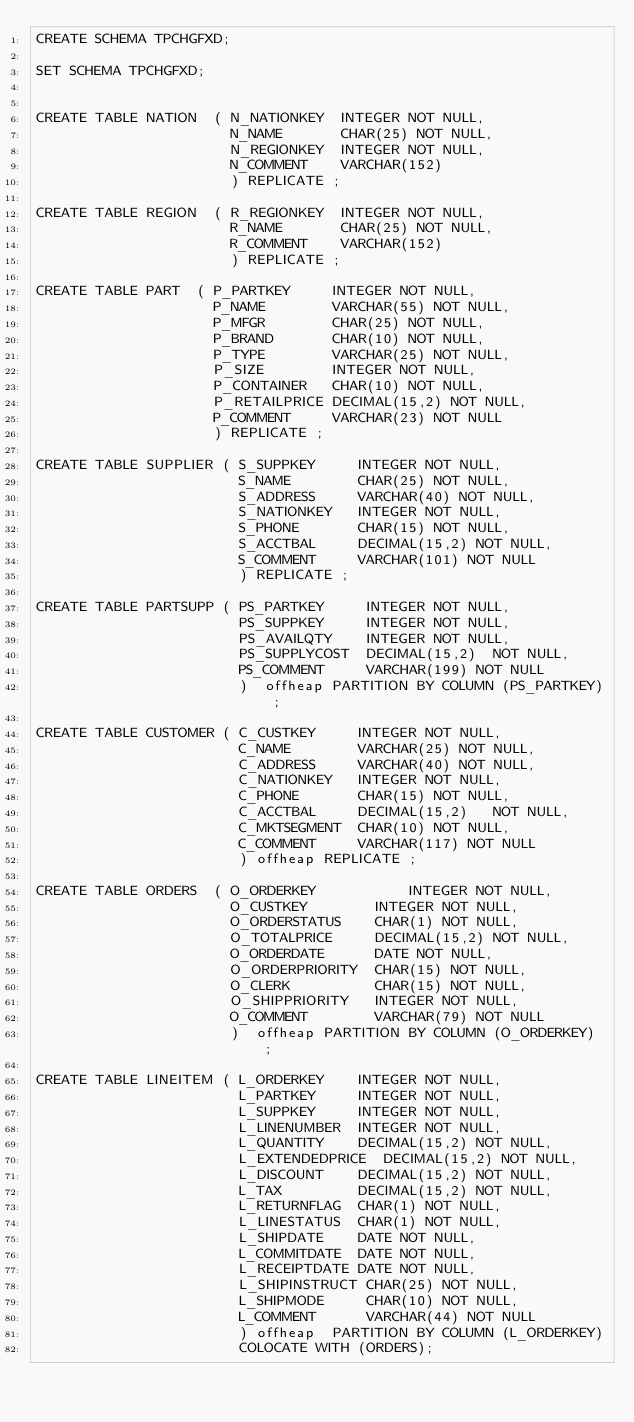<code> <loc_0><loc_0><loc_500><loc_500><_SQL_>CREATE SCHEMA TPCHGFXD;

SET SCHEMA TPCHGFXD;


CREATE TABLE NATION  ( N_NATIONKEY  INTEGER NOT NULL,
                       N_NAME       CHAR(25) NOT NULL,
                       N_REGIONKEY  INTEGER NOT NULL,
                       N_COMMENT    VARCHAR(152)
                       ) REPLICATE ;

CREATE TABLE REGION  ( R_REGIONKEY  INTEGER NOT NULL,
                       R_NAME       CHAR(25) NOT NULL,
                       R_COMMENT    VARCHAR(152)
                       ) REPLICATE ;

CREATE TABLE PART  ( P_PARTKEY     INTEGER NOT NULL,
                     P_NAME        VARCHAR(55) NOT NULL,
                     P_MFGR        CHAR(25) NOT NULL,
                     P_BRAND       CHAR(10) NOT NULL,
                     P_TYPE        VARCHAR(25) NOT NULL,
                     P_SIZE        INTEGER NOT NULL,
                     P_CONTAINER   CHAR(10) NOT NULL,
                     P_RETAILPRICE DECIMAL(15,2) NOT NULL,
                     P_COMMENT     VARCHAR(23) NOT NULL 
                     ) REPLICATE ;

CREATE TABLE SUPPLIER ( S_SUPPKEY     INTEGER NOT NULL,
                        S_NAME        CHAR(25) NOT NULL,
                        S_ADDRESS     VARCHAR(40) NOT NULL,
                        S_NATIONKEY   INTEGER NOT NULL,
                        S_PHONE       CHAR(15) NOT NULL,
                        S_ACCTBAL     DECIMAL(15,2) NOT NULL,
                        S_COMMENT     VARCHAR(101) NOT NULL
                        ) REPLICATE ;
 
CREATE TABLE PARTSUPP ( PS_PARTKEY     INTEGER NOT NULL,
                        PS_SUPPKEY     INTEGER NOT NULL,
                        PS_AVAILQTY    INTEGER NOT NULL,
                        PS_SUPPLYCOST  DECIMAL(15,2)  NOT NULL,
                        PS_COMMENT     VARCHAR(199) NOT NULL 
                        )  offheap PARTITION BY COLUMN (PS_PARTKEY);

CREATE TABLE CUSTOMER ( C_CUSTKEY     INTEGER NOT NULL,
                        C_NAME        VARCHAR(25) NOT NULL,
                        C_ADDRESS     VARCHAR(40) NOT NULL,
                        C_NATIONKEY   INTEGER NOT NULL,
                        C_PHONE       CHAR(15) NOT NULL,
                        C_ACCTBAL     DECIMAL(15,2)   NOT NULL,
                        C_MKTSEGMENT  CHAR(10) NOT NULL,
                        C_COMMENT     VARCHAR(117) NOT NULL
                        ) offheap REPLICATE ; 

CREATE TABLE ORDERS  ( O_ORDERKEY           INTEGER NOT NULL,
                       O_CUSTKEY        INTEGER NOT NULL,
                       O_ORDERSTATUS    CHAR(1) NOT NULL,
                       O_TOTALPRICE     DECIMAL(15,2) NOT NULL,
                       O_ORDERDATE      DATE NOT NULL,
                       O_ORDERPRIORITY  CHAR(15) NOT NULL,
                       O_CLERK          CHAR(15) NOT NULL,
                       O_SHIPPRIORITY   INTEGER NOT NULL,
                       O_COMMENT        VARCHAR(79) NOT NULL
                       )  offheap PARTITION BY COLUMN (O_ORDERKEY) ;

CREATE TABLE LINEITEM ( L_ORDERKEY    INTEGER NOT NULL,
                        L_PARTKEY     INTEGER NOT NULL,
                        L_SUPPKEY     INTEGER NOT NULL,
                        L_LINENUMBER  INTEGER NOT NULL,
                        L_QUANTITY    DECIMAL(15,2) NOT NULL,
                        L_EXTENDEDPRICE  DECIMAL(15,2) NOT NULL,
                        L_DISCOUNT    DECIMAL(15,2) NOT NULL,
                        L_TAX         DECIMAL(15,2) NOT NULL,
                        L_RETURNFLAG  CHAR(1) NOT NULL,
                        L_LINESTATUS  CHAR(1) NOT NULL,
                        L_SHIPDATE    DATE NOT NULL,
                        L_COMMITDATE  DATE NOT NULL,
                        L_RECEIPTDATE DATE NOT NULL,
                        L_SHIPINSTRUCT CHAR(25) NOT NULL,
                        L_SHIPMODE     CHAR(10) NOT NULL,
                        L_COMMENT      VARCHAR(44) NOT NULL
                        ) offheap  PARTITION BY COLUMN (L_ORDERKEY)
                        COLOCATE WITH (ORDERS);
</code> 